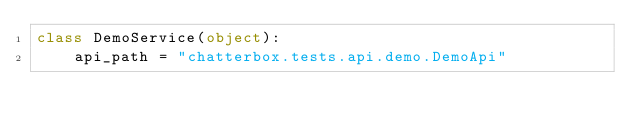Convert code to text. <code><loc_0><loc_0><loc_500><loc_500><_Python_>class DemoService(object):
    api_path = "chatterbox.tests.api.demo.DemoApi"
</code> 